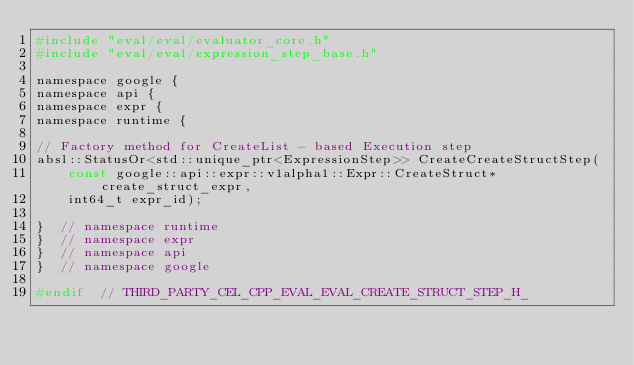<code> <loc_0><loc_0><loc_500><loc_500><_C_>#include "eval/eval/evaluator_core.h"
#include "eval/eval/expression_step_base.h"

namespace google {
namespace api {
namespace expr {
namespace runtime {

// Factory method for CreateList - based Execution step
absl::StatusOr<std::unique_ptr<ExpressionStep>> CreateCreateStructStep(
    const google::api::expr::v1alpha1::Expr::CreateStruct* create_struct_expr,
    int64_t expr_id);

}  // namespace runtime
}  // namespace expr
}  // namespace api
}  // namespace google

#endif  // THIRD_PARTY_CEL_CPP_EVAL_EVAL_CREATE_STRUCT_STEP_H_
</code> 